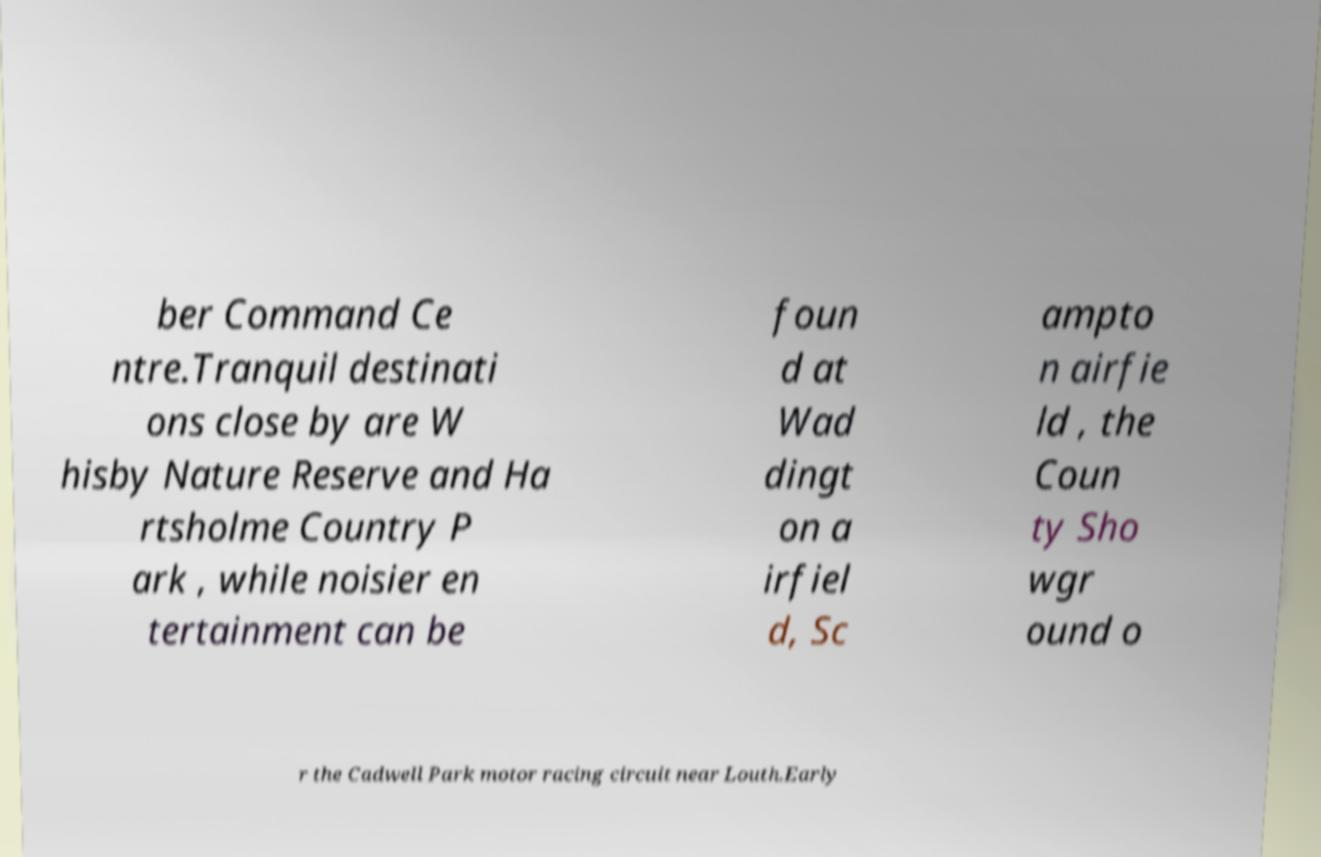Please read and relay the text visible in this image. What does it say? ber Command Ce ntre.Tranquil destinati ons close by are W hisby Nature Reserve and Ha rtsholme Country P ark , while noisier en tertainment can be foun d at Wad dingt on a irfiel d, Sc ampto n airfie ld , the Coun ty Sho wgr ound o r the Cadwell Park motor racing circuit near Louth.Early 